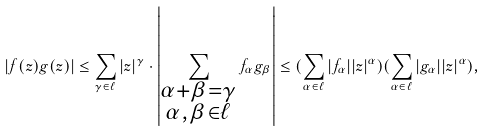Convert formula to latex. <formula><loc_0><loc_0><loc_500><loc_500>| f ( z ) g ( z ) | \leq \sum _ { \gamma \in \ell } | z | ^ { \gamma } \cdot \left | \sum _ { \substack { \alpha + \beta = \gamma \\ \alpha , \beta \in \ell } } f _ { \alpha } g _ { \beta } \right | \leq ( \sum _ { \alpha \in \ell } | f _ { \alpha } | | z | ^ { \alpha } ) ( \sum _ { \alpha \in \ell } | g _ { \alpha } | | z | ^ { \alpha } ) ,</formula> 